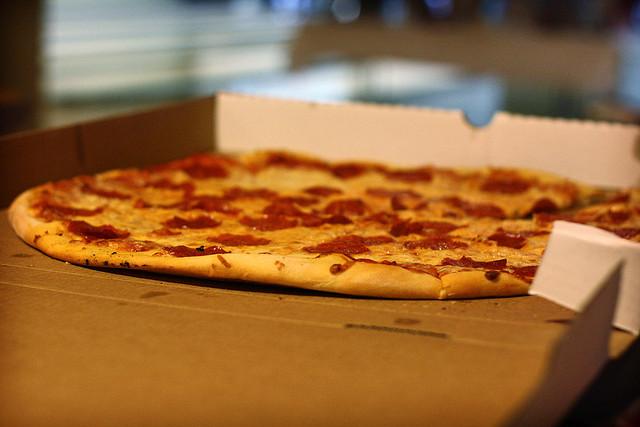Has the pizza been cut?
Keep it brief. Yes. Has anyone eaten a slice of this pizza yet?
Keep it brief. No. Is the from the store or homemade?
Concise answer only. Store. How many topping slices do you see?
Write a very short answer. 1. What does this pizza have on it?
Short answer required. Pepperoni. 